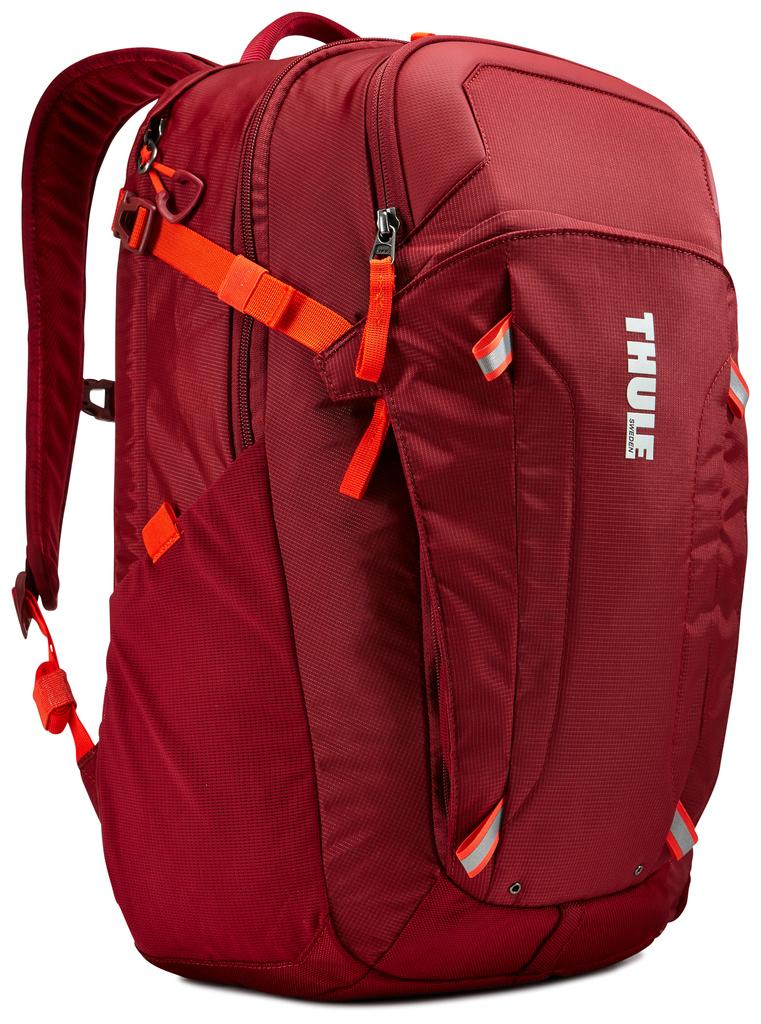<image>
Describe the image concisely. A small daypack made by the company Thule. 